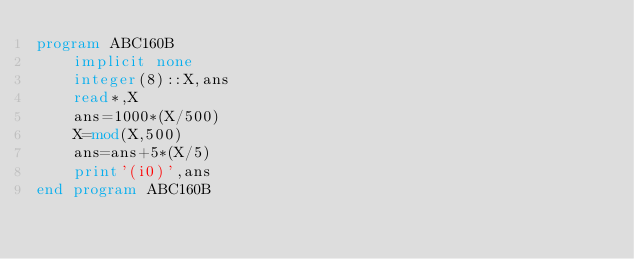Convert code to text. <code><loc_0><loc_0><loc_500><loc_500><_FORTRAN_>program ABC160B
    implicit none
    integer(8)::X,ans
    read*,X
    ans=1000*(X/500)
    X=mod(X,500)
    ans=ans+5*(X/5)
    print'(i0)',ans
end program ABC160B</code> 